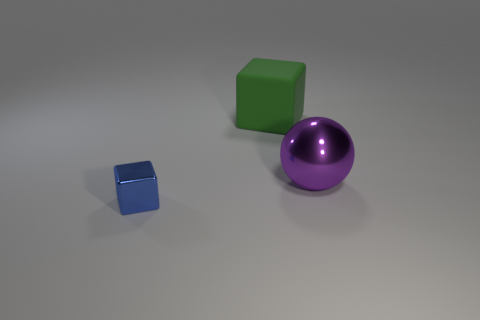Add 1 tiny blocks. How many objects exist? 4 Subtract all spheres. How many objects are left? 2 Subtract all large blocks. Subtract all tiny shiny things. How many objects are left? 1 Add 2 green rubber cubes. How many green rubber cubes are left? 3 Add 2 small brown objects. How many small brown objects exist? 2 Subtract all blue cubes. How many cubes are left? 1 Subtract 0 purple cylinders. How many objects are left? 3 Subtract 2 cubes. How many cubes are left? 0 Subtract all cyan spheres. Subtract all blue cylinders. How many spheres are left? 1 Subtract all brown spheres. How many green blocks are left? 1 